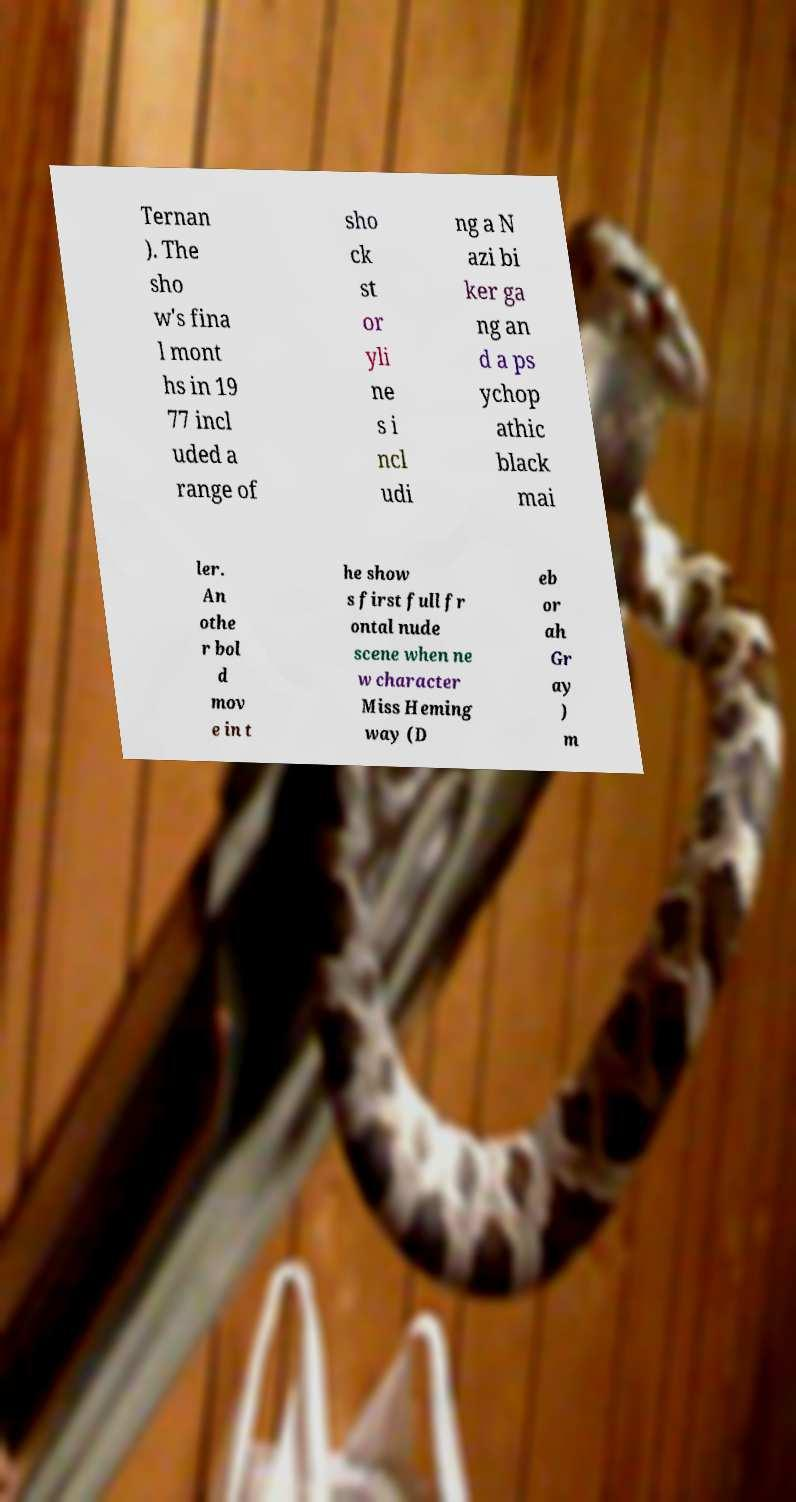Could you extract and type out the text from this image? Ternan ). The sho w's fina l mont hs in 19 77 incl uded a range of sho ck st or yli ne s i ncl udi ng a N azi bi ker ga ng an d a ps ychop athic black mai ler. An othe r bol d mov e in t he show s first full fr ontal nude scene when ne w character Miss Heming way (D eb or ah Gr ay ) m 